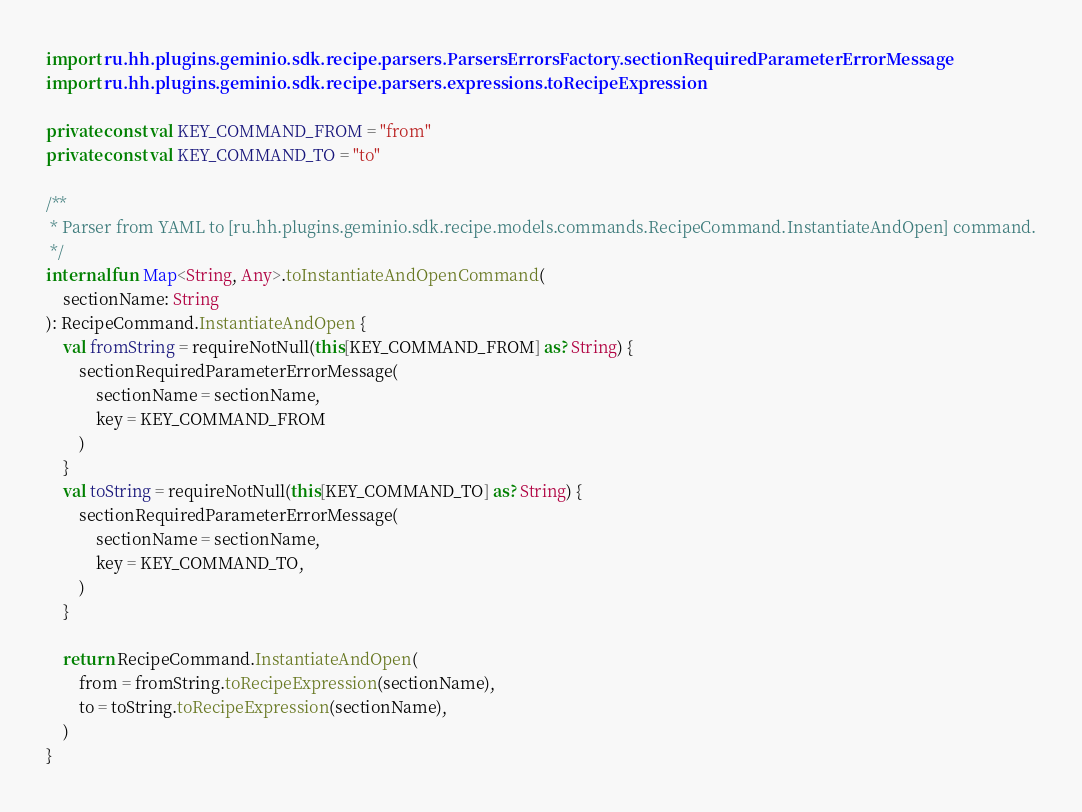Convert code to text. <code><loc_0><loc_0><loc_500><loc_500><_Kotlin_>import ru.hh.plugins.geminio.sdk.recipe.parsers.ParsersErrorsFactory.sectionRequiredParameterErrorMessage
import ru.hh.plugins.geminio.sdk.recipe.parsers.expressions.toRecipeExpression

private const val KEY_COMMAND_FROM = "from"
private const val KEY_COMMAND_TO = "to"

/**
 * Parser from YAML to [ru.hh.plugins.geminio.sdk.recipe.models.commands.RecipeCommand.InstantiateAndOpen] command.
 */
internal fun Map<String, Any>.toInstantiateAndOpenCommand(
    sectionName: String
): RecipeCommand.InstantiateAndOpen {
    val fromString = requireNotNull(this[KEY_COMMAND_FROM] as? String) {
        sectionRequiredParameterErrorMessage(
            sectionName = sectionName,
            key = KEY_COMMAND_FROM
        )
    }
    val toString = requireNotNull(this[KEY_COMMAND_TO] as? String) {
        sectionRequiredParameterErrorMessage(
            sectionName = sectionName,
            key = KEY_COMMAND_TO,
        )
    }

    return RecipeCommand.InstantiateAndOpen(
        from = fromString.toRecipeExpression(sectionName),
        to = toString.toRecipeExpression(sectionName),
    )
}
</code> 